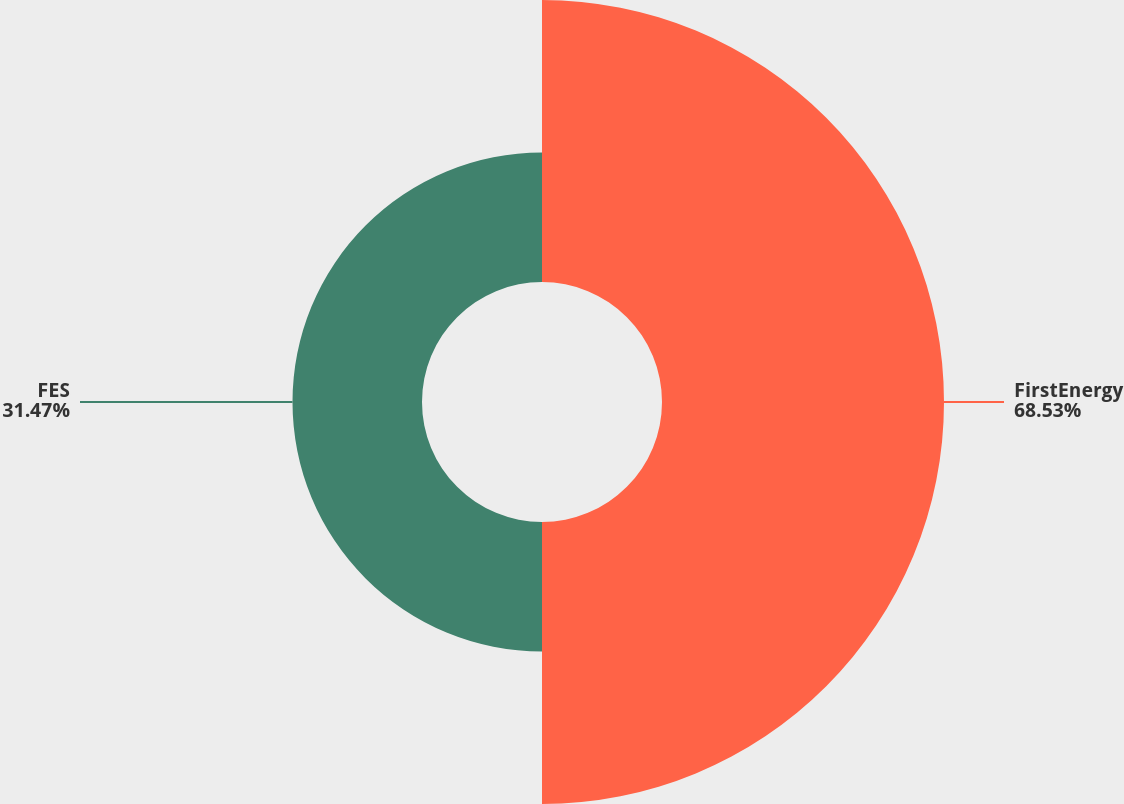Convert chart to OTSL. <chart><loc_0><loc_0><loc_500><loc_500><pie_chart><fcel>FirstEnergy<fcel>FES<nl><fcel>68.53%<fcel>31.47%<nl></chart> 